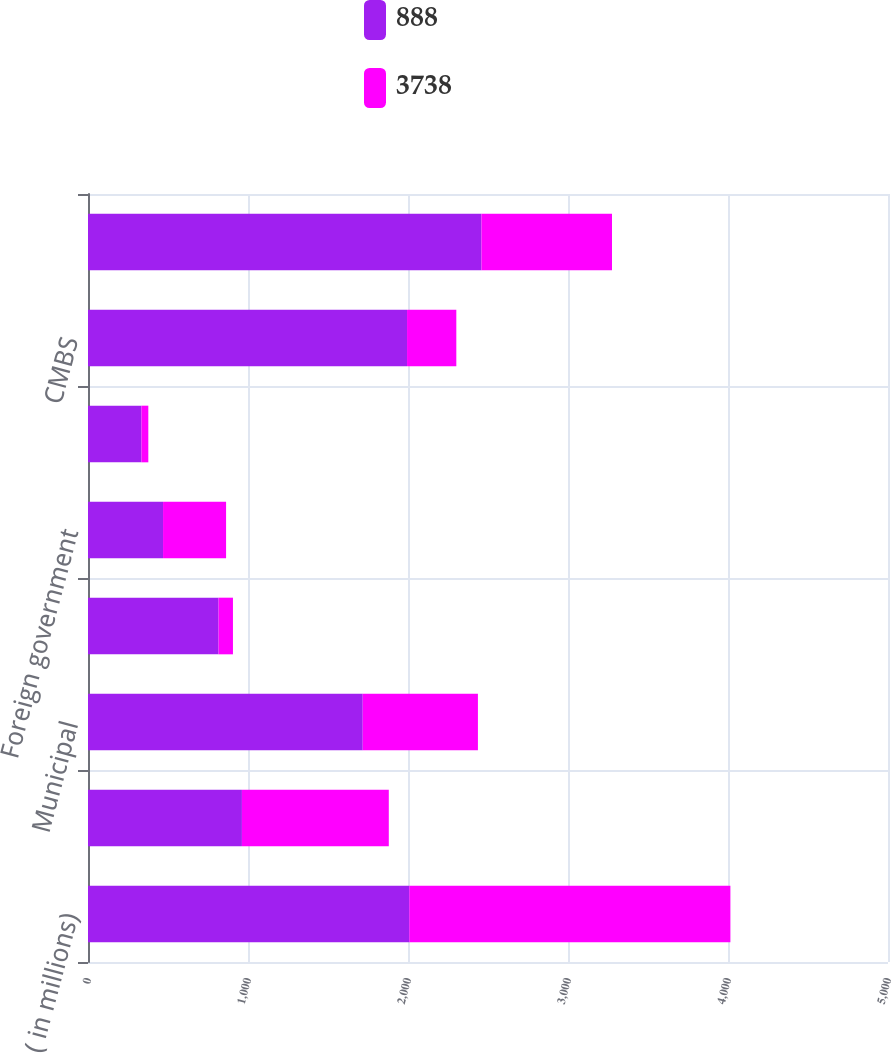Convert chart. <chart><loc_0><loc_0><loc_500><loc_500><stacked_bar_chart><ecel><fcel>( in millions)<fcel>US government and agencies<fcel>Municipal<fcel>Corporate<fcel>Foreign government<fcel>MBS<fcel>CMBS<fcel>ABS<nl><fcel>888<fcel>2008<fcel>962<fcel>1717<fcel>816<fcel>469<fcel>334<fcel>1994<fcel>2459<nl><fcel>3738<fcel>2007<fcel>918<fcel>720<fcel>90<fcel>394<fcel>43<fcel>308<fcel>816<nl></chart> 